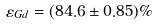<formula> <loc_0><loc_0><loc_500><loc_500>\varepsilon _ { G d } = ( 8 4 . 6 \pm 0 . 8 5 ) \%</formula> 